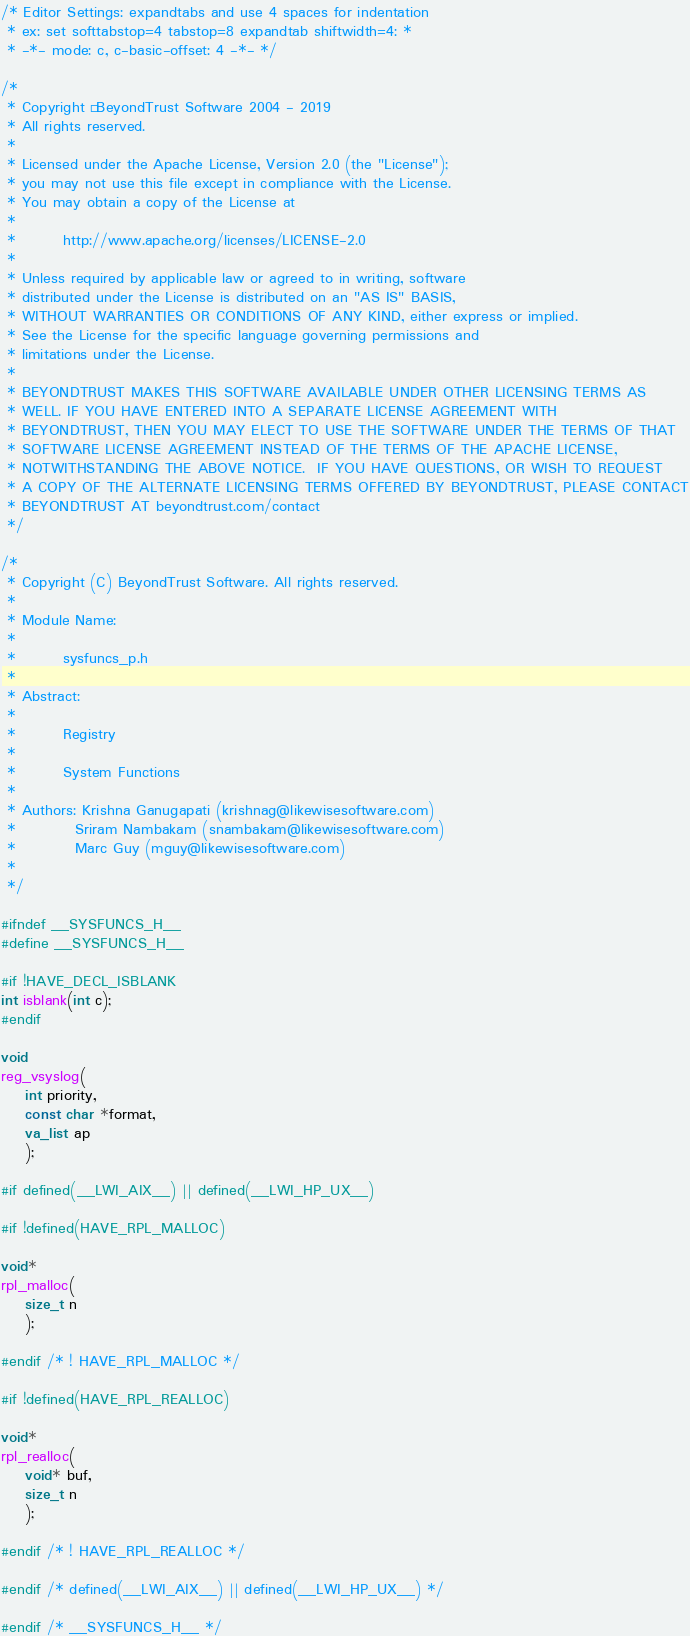Convert code to text. <code><loc_0><loc_0><loc_500><loc_500><_C_>/* Editor Settings: expandtabs and use 4 spaces for indentation
 * ex: set softtabstop=4 tabstop=8 expandtab shiftwidth=4: *
 * -*- mode: c, c-basic-offset: 4 -*- */

/*
 * Copyright © BeyondTrust Software 2004 - 2019
 * All rights reserved.
 *
 * Licensed under the Apache License, Version 2.0 (the "License");
 * you may not use this file except in compliance with the License.
 * You may obtain a copy of the License at
 *
 *        http://www.apache.org/licenses/LICENSE-2.0
 *
 * Unless required by applicable law or agreed to in writing, software
 * distributed under the License is distributed on an "AS IS" BASIS,
 * WITHOUT WARRANTIES OR CONDITIONS OF ANY KIND, either express or implied.
 * See the License for the specific language governing permissions and
 * limitations under the License.
 *
 * BEYONDTRUST MAKES THIS SOFTWARE AVAILABLE UNDER OTHER LICENSING TERMS AS
 * WELL. IF YOU HAVE ENTERED INTO A SEPARATE LICENSE AGREEMENT WITH
 * BEYONDTRUST, THEN YOU MAY ELECT TO USE THE SOFTWARE UNDER THE TERMS OF THAT
 * SOFTWARE LICENSE AGREEMENT INSTEAD OF THE TERMS OF THE APACHE LICENSE,
 * NOTWITHSTANDING THE ABOVE NOTICE.  IF YOU HAVE QUESTIONS, OR WISH TO REQUEST
 * A COPY OF THE ALTERNATE LICENSING TERMS OFFERED BY BEYONDTRUST, PLEASE CONTACT
 * BEYONDTRUST AT beyondtrust.com/contact
 */

/*
 * Copyright (C) BeyondTrust Software. All rights reserved.
 *
 * Module Name:
 *
 *        sysfuncs_p.h
 *
 * Abstract:
 *
 *        Registry
 *
 *        System Functions
 *
 * Authors: Krishna Ganugapati (krishnag@likewisesoftware.com)
 *          Sriram Nambakam (snambakam@likewisesoftware.com)
 *          Marc Guy (mguy@likewisesoftware.com)
 *
 */

#ifndef __SYSFUNCS_H__
#define __SYSFUNCS_H__

#if !HAVE_DECL_ISBLANK
int isblank(int c);
#endif

void
reg_vsyslog(
    int priority,
    const char *format,
    va_list ap
    );

#if defined(__LWI_AIX__) || defined(__LWI_HP_UX__)

#if !defined(HAVE_RPL_MALLOC)

void*
rpl_malloc(
    size_t n
    );

#endif /* ! HAVE_RPL_MALLOC */

#if !defined(HAVE_RPL_REALLOC)

void*
rpl_realloc(
    void* buf,
    size_t n
    );

#endif /* ! HAVE_RPL_REALLOC */

#endif /* defined(__LWI_AIX__) || defined(__LWI_HP_UX__) */

#endif /* __SYSFUNCS_H__ */

</code> 